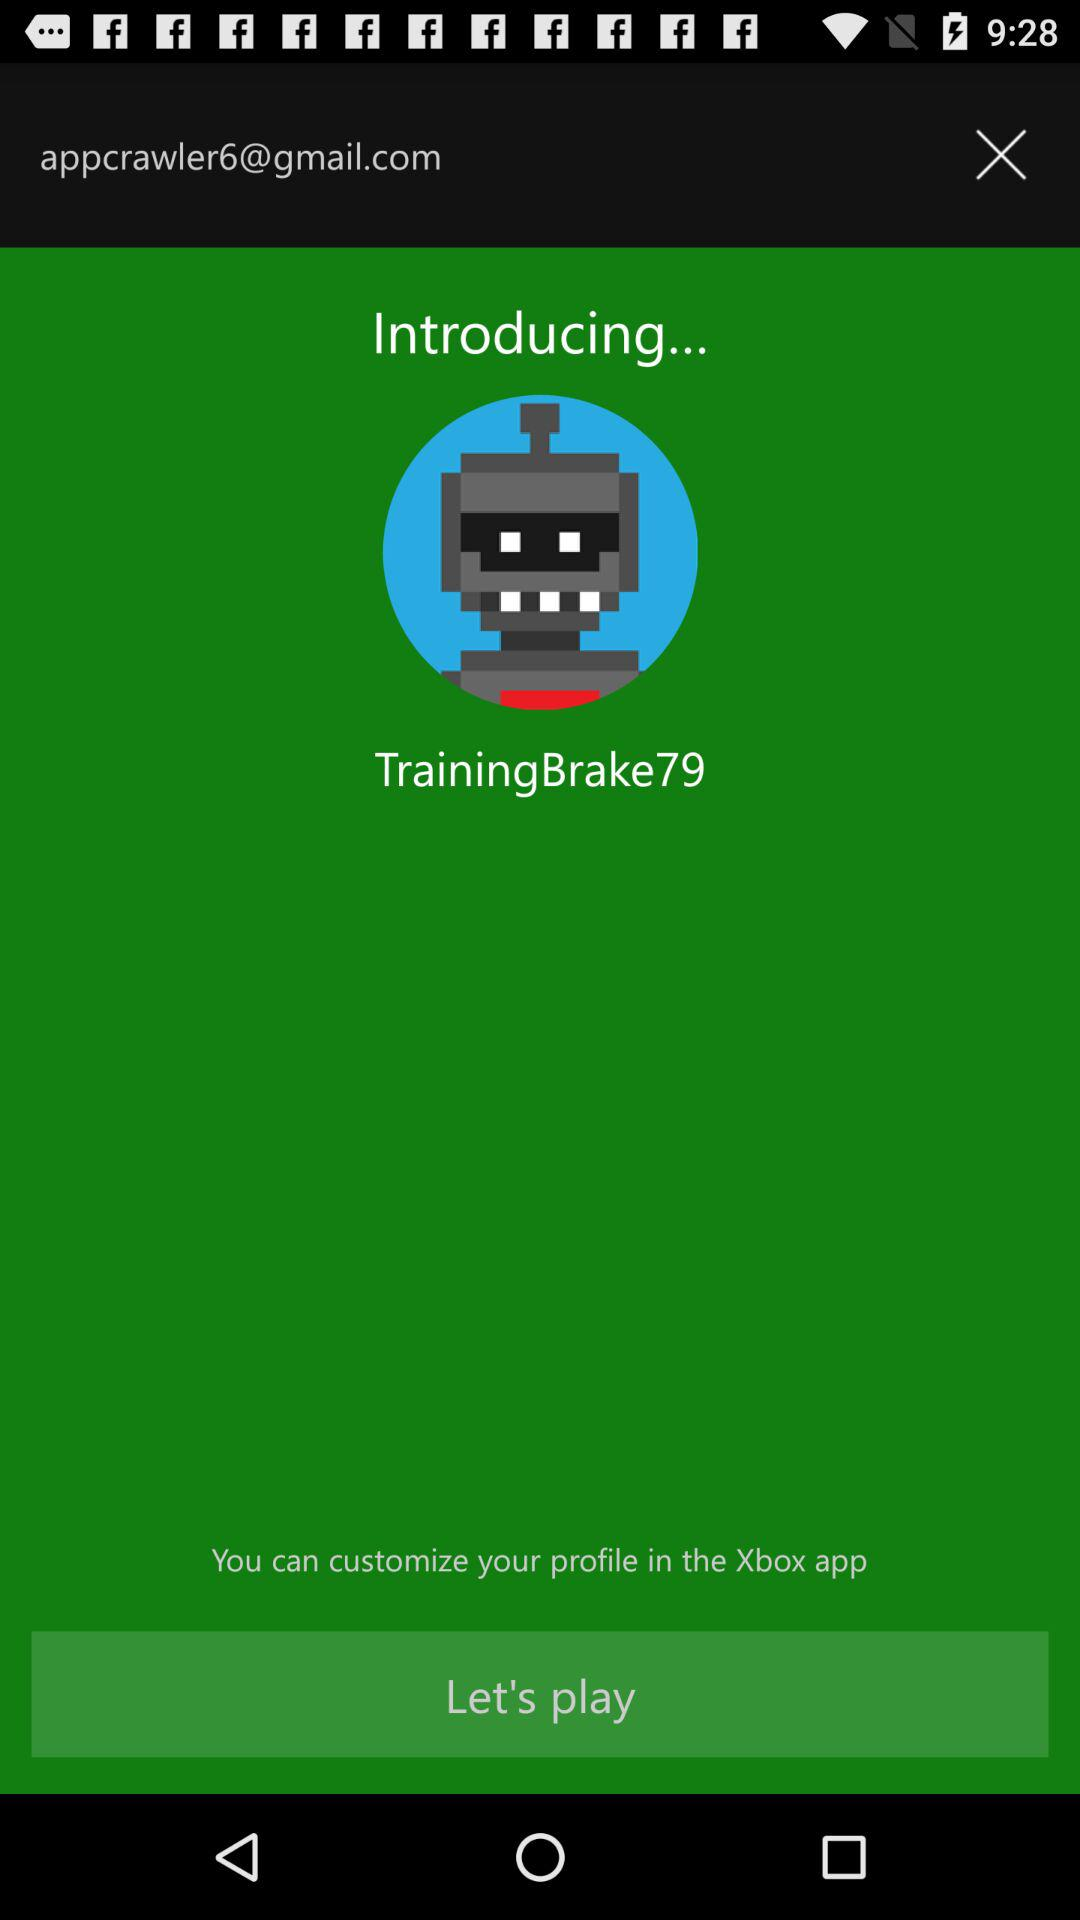What is the email address? The email address is appcrawler6@gmail.com. 